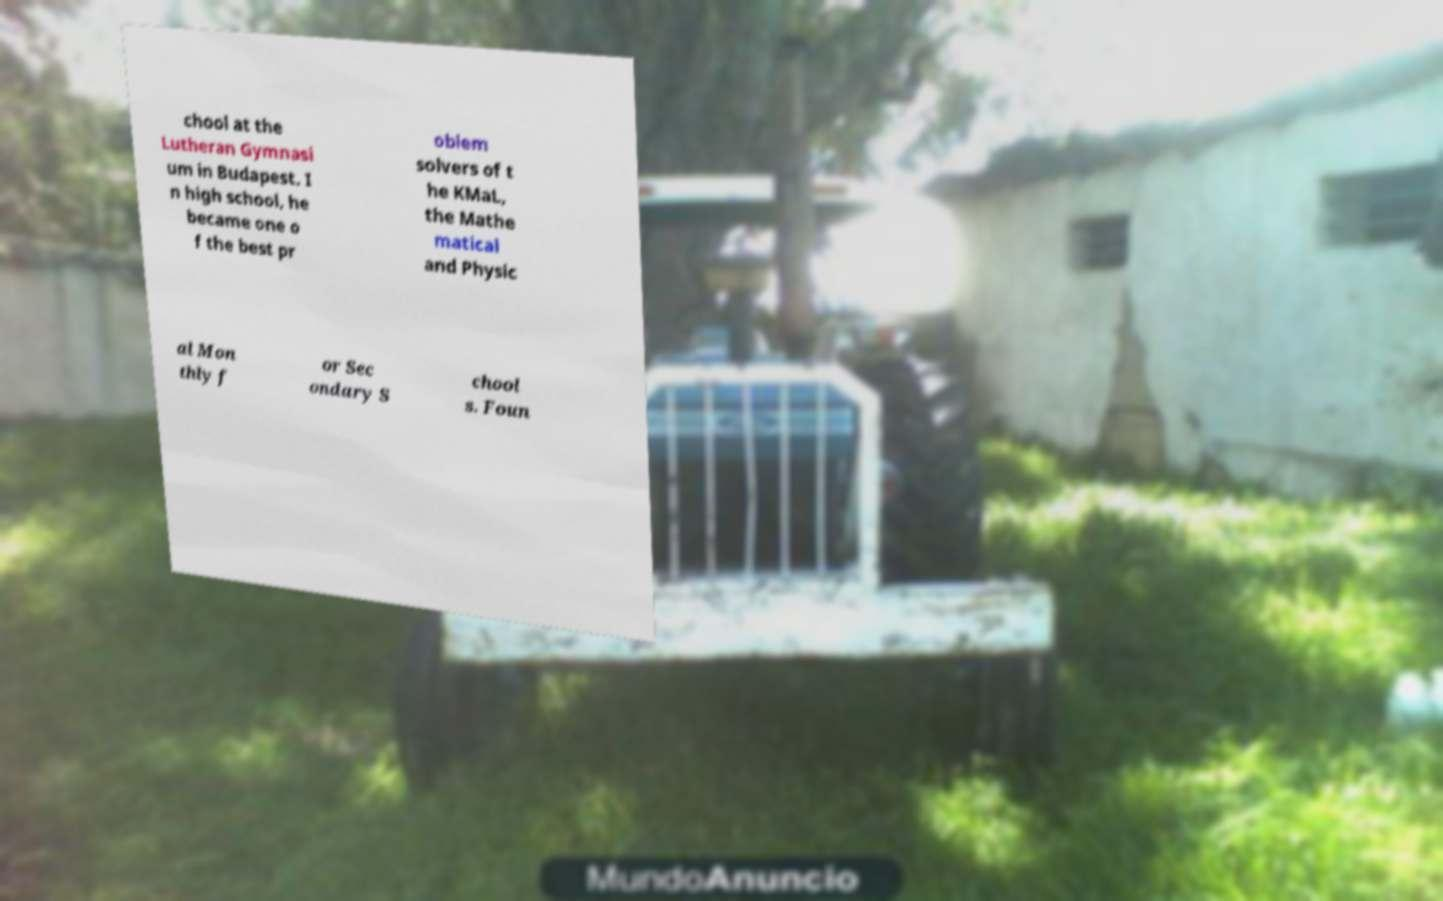Please identify and transcribe the text found in this image. chool at the Lutheran Gymnasi um in Budapest. I n high school, he became one o f the best pr oblem solvers of t he KMaL, the Mathe matical and Physic al Mon thly f or Sec ondary S chool s. Foun 